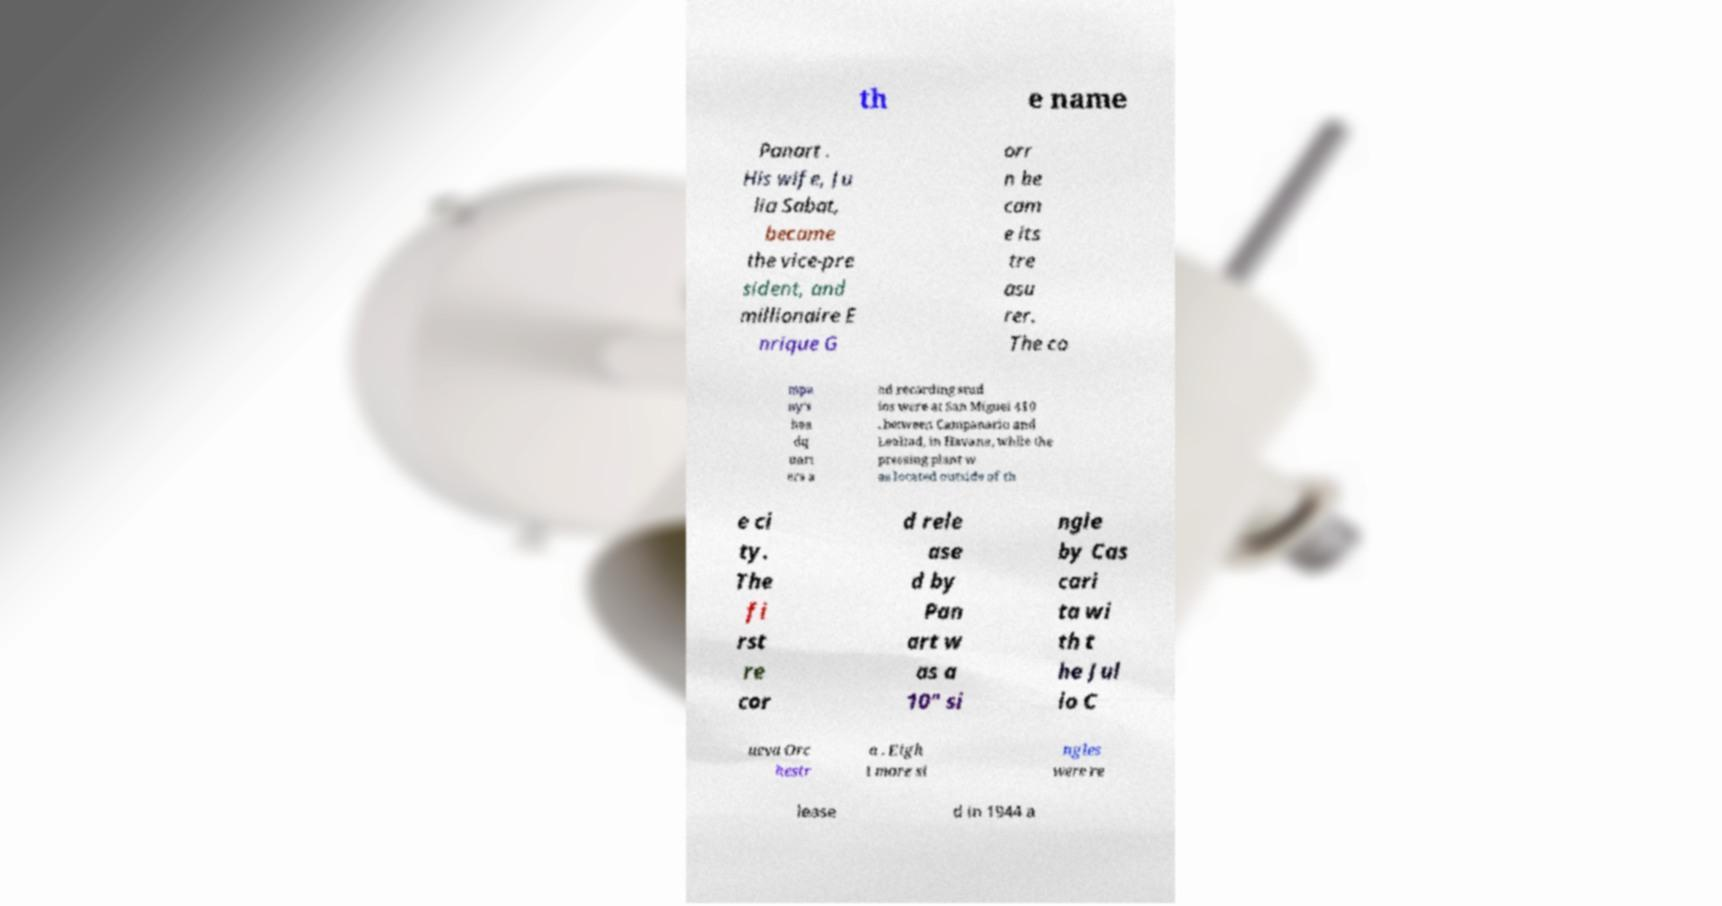Please read and relay the text visible in this image. What does it say? th e name Panart . His wife, Ju lia Sabat, became the vice-pre sident, and millionaire E nrique G orr n be cam e its tre asu rer. The co mpa ny's hea dq uart ers a nd recording stud ios were at San Miguel 410 , between Campanario and Lealtad, in Havana, while the pressing plant w as located outside of th e ci ty. The fi rst re cor d rele ase d by Pan art w as a 10" si ngle by Cas cari ta wi th t he Jul io C ueva Orc hestr a . Eigh t more si ngles were re lease d in 1944 a 